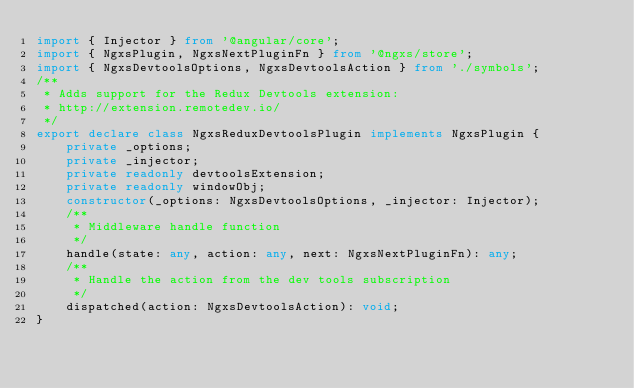<code> <loc_0><loc_0><loc_500><loc_500><_TypeScript_>import { Injector } from '@angular/core';
import { NgxsPlugin, NgxsNextPluginFn } from '@ngxs/store';
import { NgxsDevtoolsOptions, NgxsDevtoolsAction } from './symbols';
/**
 * Adds support for the Redux Devtools extension:
 * http://extension.remotedev.io/
 */
export declare class NgxsReduxDevtoolsPlugin implements NgxsPlugin {
    private _options;
    private _injector;
    private readonly devtoolsExtension;
    private readonly windowObj;
    constructor(_options: NgxsDevtoolsOptions, _injector: Injector);
    /**
     * Middleware handle function
     */
    handle(state: any, action: any, next: NgxsNextPluginFn): any;
    /**
     * Handle the action from the dev tools subscription
     */
    dispatched(action: NgxsDevtoolsAction): void;
}
</code> 